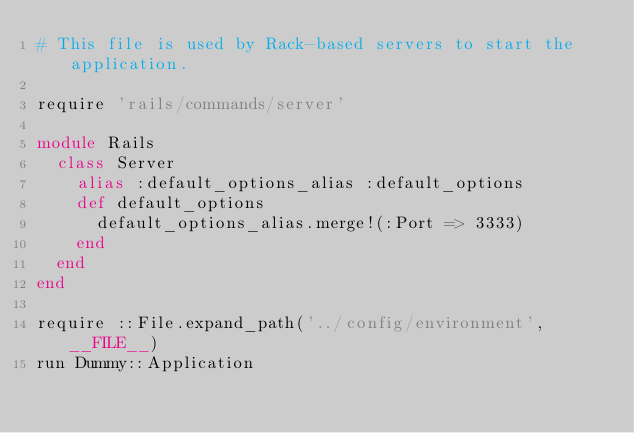<code> <loc_0><loc_0><loc_500><loc_500><_Ruby_># This file is used by Rack-based servers to start the application.

require 'rails/commands/server'

module Rails
  class Server
    alias :default_options_alias :default_options
    def default_options
      default_options_alias.merge!(:Port => 3333)
    end
  end
end

require ::File.expand_path('../config/environment',  __FILE__)
run Dummy::Application
</code> 